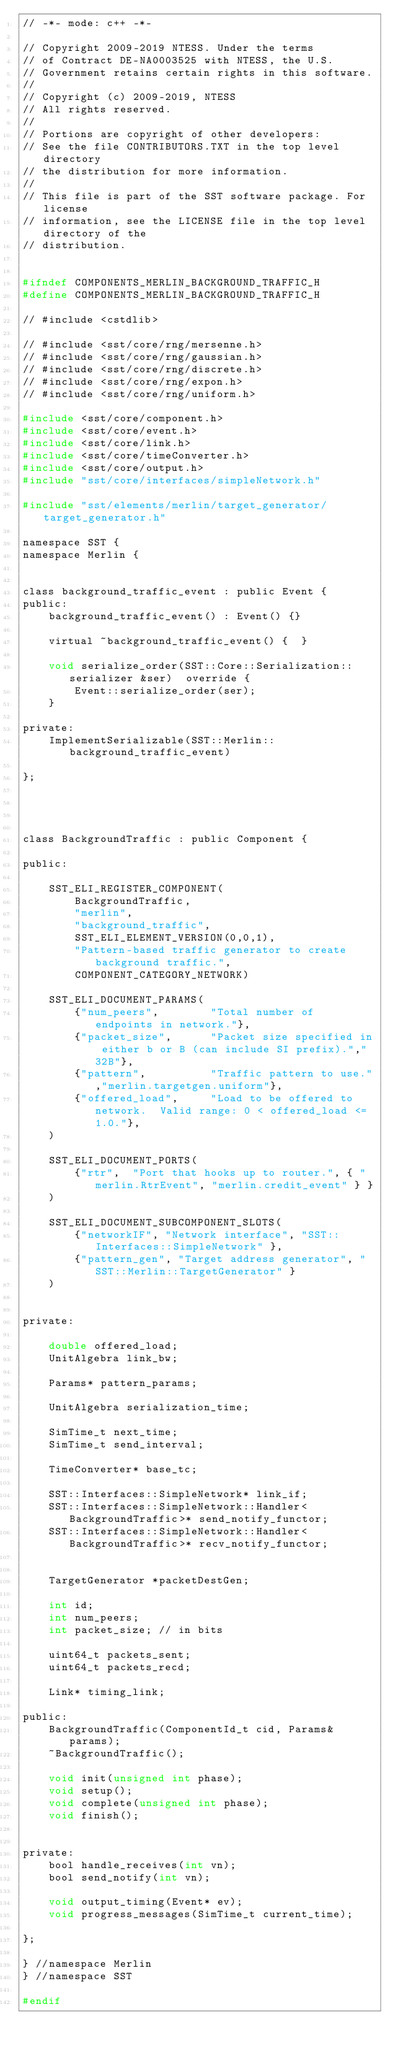<code> <loc_0><loc_0><loc_500><loc_500><_C_>// -*- mode: c++ -*-

// Copyright 2009-2019 NTESS. Under the terms
// of Contract DE-NA0003525 with NTESS, the U.S.
// Government retains certain rights in this software.
//
// Copyright (c) 2009-2019, NTESS
// All rights reserved.
//
// Portions are copyright of other developers:
// See the file CONTRIBUTORS.TXT in the top level directory
// the distribution for more information.
//
// This file is part of the SST software package. For license
// information, see the LICENSE file in the top level directory of the
// distribution.


#ifndef COMPONENTS_MERLIN_BACKGROUND_TRAFFIC_H
#define COMPONENTS_MERLIN_BACKGROUND_TRAFFIC_H

// #include <cstdlib>

// #include <sst/core/rng/mersenne.h>
// #include <sst/core/rng/gaussian.h>
// #include <sst/core/rng/discrete.h>
// #include <sst/core/rng/expon.h>
// #include <sst/core/rng/uniform.h>

#include <sst/core/component.h>
#include <sst/core/event.h>
#include <sst/core/link.h>
#include <sst/core/timeConverter.h>
#include <sst/core/output.h>
#include "sst/core/interfaces/simpleNetwork.h"

#include "sst/elements/merlin/target_generator/target_generator.h"

namespace SST {
namespace Merlin {


class background_traffic_event : public Event {
public:
    background_traffic_event() : Event() {}

    virtual ~background_traffic_event() {  }

    void serialize_order(SST::Core::Serialization::serializer &ser)  override {
        Event::serialize_order(ser);
    }

private:
    ImplementSerializable(SST::Merlin::background_traffic_event)

};




class BackgroundTraffic : public Component {

public:

    SST_ELI_REGISTER_COMPONENT(
        BackgroundTraffic,
        "merlin",
        "background_traffic",
        SST_ELI_ELEMENT_VERSION(0,0,1),
        "Pattern-based traffic generator to create background traffic.",
        COMPONENT_CATEGORY_NETWORK)
    
    SST_ELI_DOCUMENT_PARAMS(
        {"num_peers",        "Total number of endpoints in network."},
        {"packet_size",      "Packet size specified in either b or B (can include SI prefix).","32B"},
        {"pattern",          "Traffic pattern to use.","merlin.targetgen.uniform"},
        {"offered_load",     "Load to be offered to network.  Valid range: 0 < offered_load <= 1.0."},
    )

    SST_ELI_DOCUMENT_PORTS(
        {"rtr",  "Port that hooks up to router.", { "merlin.RtrEvent", "merlin.credit_event" } }
    )
 
    SST_ELI_DOCUMENT_SUBCOMPONENT_SLOTS(
        {"networkIF", "Network interface", "SST::Interfaces::SimpleNetwork" },
        {"pattern_gen", "Target address generator", "SST::Merlin::TargetGenerator" }
    )


private:

    double offered_load;
    UnitAlgebra link_bw;

    Params* pattern_params;
    
    UnitAlgebra serialization_time;
    
    SimTime_t next_time;
    SimTime_t send_interval;

    TimeConverter* base_tc;

    SST::Interfaces::SimpleNetwork* link_if;
    SST::Interfaces::SimpleNetwork::Handler<BackgroundTraffic>* send_notify_functor;
    SST::Interfaces::SimpleNetwork::Handler<BackgroundTraffic>* recv_notify_functor;


    TargetGenerator *packetDestGen;
    
    int id;
    int num_peers;
    int packet_size; // in bits
    
    uint64_t packets_sent;
    uint64_t packets_recd;

    Link* timing_link;
    
public:
    BackgroundTraffic(ComponentId_t cid, Params& params);
    ~BackgroundTraffic();

    void init(unsigned int phase);
    void setup();
    void complete(unsigned int phase);
    void finish();


private:
    bool handle_receives(int vn);
    bool send_notify(int vn);

    void output_timing(Event* ev);
    void progress_messages(SimTime_t current_time);
    
};

} //namespace Merlin
} //namespace SST

#endif
</code> 